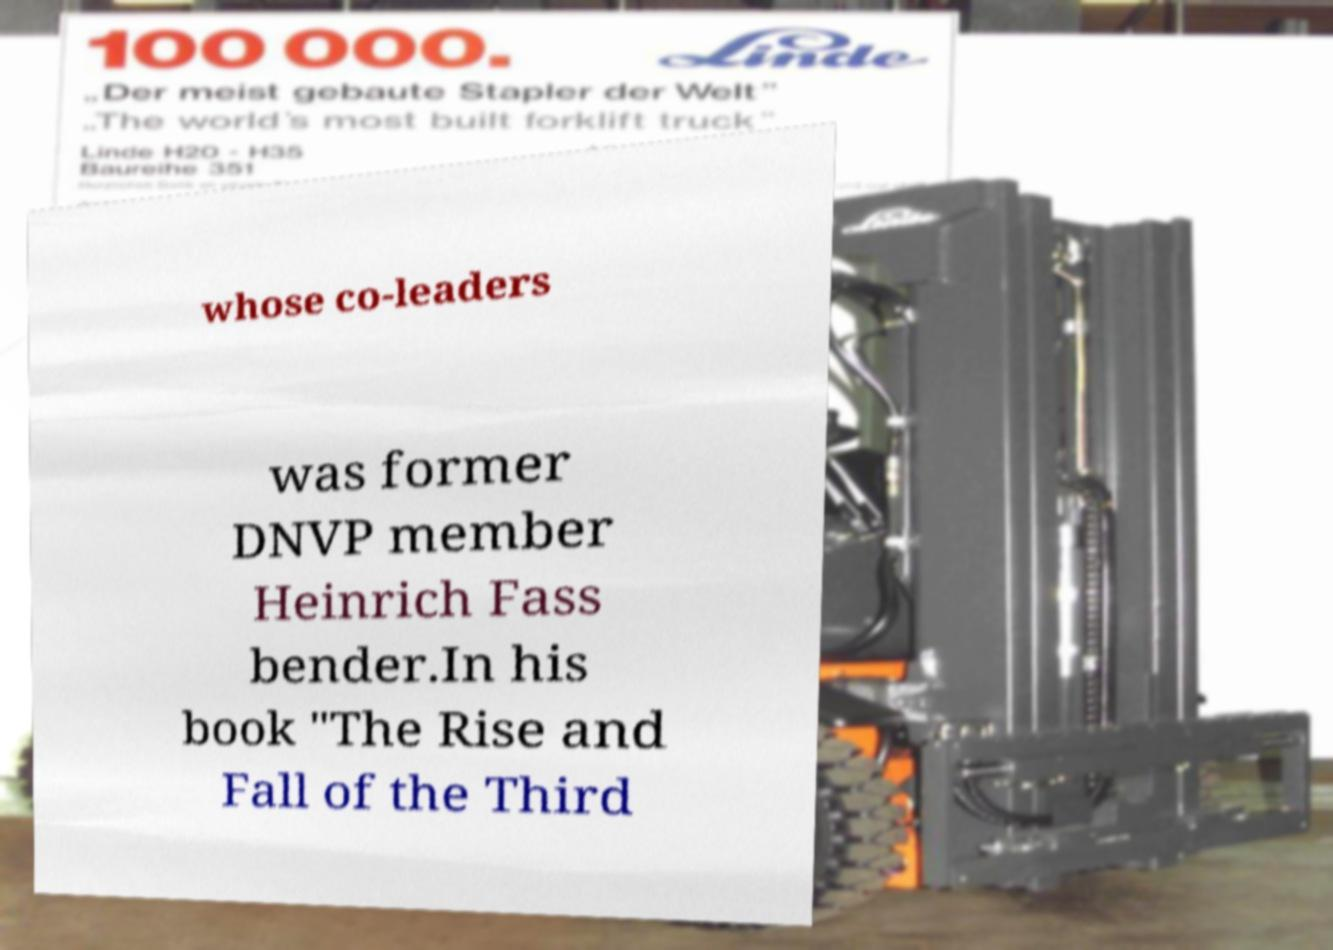Please read and relay the text visible in this image. What does it say? whose co-leaders was former DNVP member Heinrich Fass bender.In his book "The Rise and Fall of the Third 